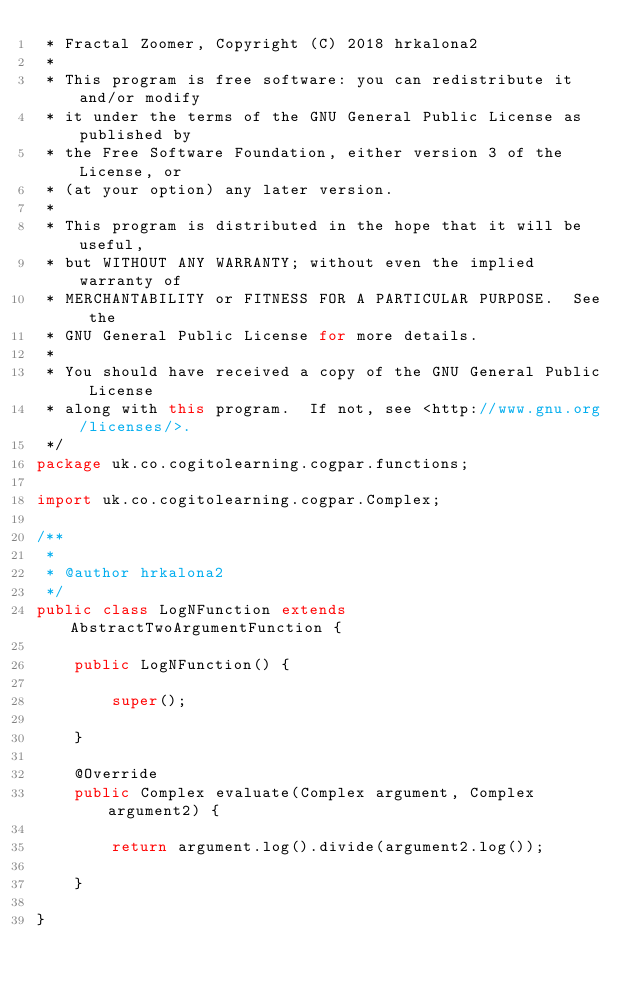Convert code to text. <code><loc_0><loc_0><loc_500><loc_500><_Java_> * Fractal Zoomer, Copyright (C) 2018 hrkalona2
 *
 * This program is free software: you can redistribute it and/or modify
 * it under the terms of the GNU General Public License as published by
 * the Free Software Foundation, either version 3 of the License, or
 * (at your option) any later version.
 *
 * This program is distributed in the hope that it will be useful,
 * but WITHOUT ANY WARRANTY; without even the implied warranty of
 * MERCHANTABILITY or FITNESS FOR A PARTICULAR PURPOSE.  See the
 * GNU General Public License for more details.
 *
 * You should have received a copy of the GNU General Public License
 * along with this program.  If not, see <http://www.gnu.org/licenses/>.
 */
package uk.co.cogitolearning.cogpar.functions;

import uk.co.cogitolearning.cogpar.Complex;

/**
 *
 * @author hrkalona2
 */
public class LogNFunction extends AbstractTwoArgumentFunction {
    
    public LogNFunction() {
        
        super();
        
    }
    
    @Override
    public Complex evaluate(Complex argument, Complex argument2) {
        
        return argument.log().divide(argument2.log());
        
    }
    
}
</code> 